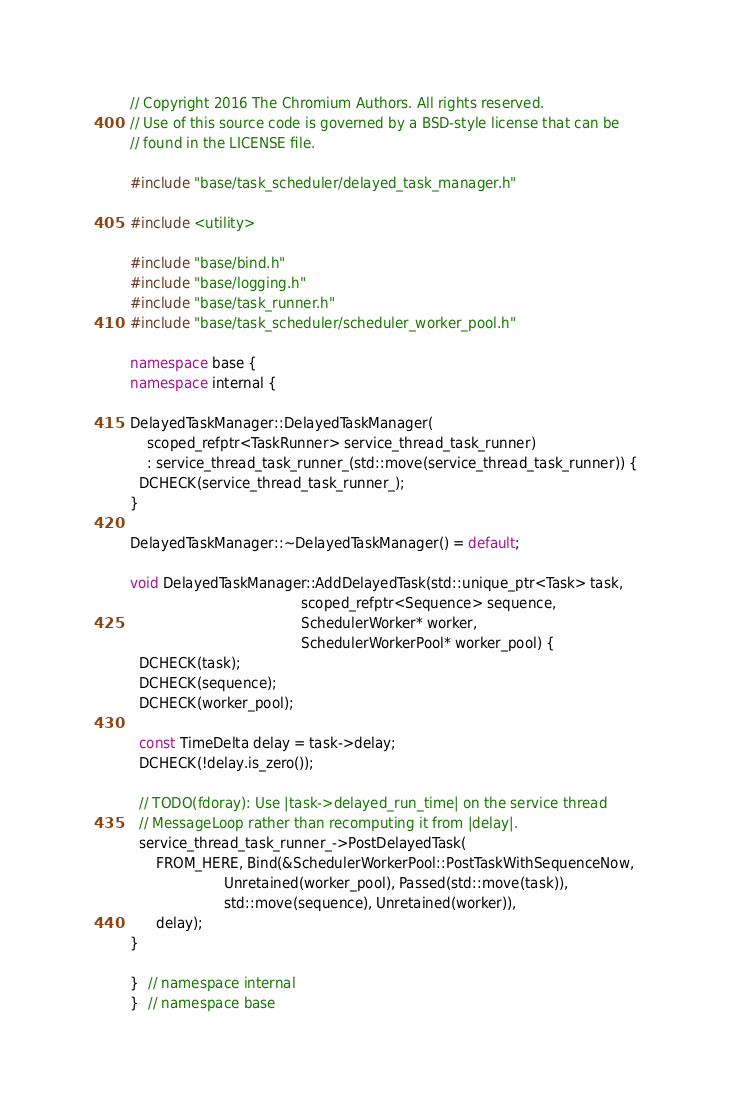Convert code to text. <code><loc_0><loc_0><loc_500><loc_500><_C++_>// Copyright 2016 The Chromium Authors. All rights reserved.
// Use of this source code is governed by a BSD-style license that can be
// found in the LICENSE file.

#include "base/task_scheduler/delayed_task_manager.h"

#include <utility>

#include "base/bind.h"
#include "base/logging.h"
#include "base/task_runner.h"
#include "base/task_scheduler/scheduler_worker_pool.h"

namespace base {
namespace internal {

DelayedTaskManager::DelayedTaskManager(
    scoped_refptr<TaskRunner> service_thread_task_runner)
    : service_thread_task_runner_(std::move(service_thread_task_runner)) {
  DCHECK(service_thread_task_runner_);
}

DelayedTaskManager::~DelayedTaskManager() = default;

void DelayedTaskManager::AddDelayedTask(std::unique_ptr<Task> task,
                                        scoped_refptr<Sequence> sequence,
                                        SchedulerWorker* worker,
                                        SchedulerWorkerPool* worker_pool) {
  DCHECK(task);
  DCHECK(sequence);
  DCHECK(worker_pool);

  const TimeDelta delay = task->delay;
  DCHECK(!delay.is_zero());

  // TODO(fdoray): Use |task->delayed_run_time| on the service thread
  // MessageLoop rather than recomputing it from |delay|.
  service_thread_task_runner_->PostDelayedTask(
      FROM_HERE, Bind(&SchedulerWorkerPool::PostTaskWithSequenceNow,
                      Unretained(worker_pool), Passed(std::move(task)),
                      std::move(sequence), Unretained(worker)),
      delay);
}

}  // namespace internal
}  // namespace base
</code> 